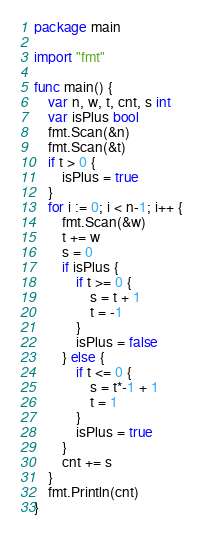Convert code to text. <code><loc_0><loc_0><loc_500><loc_500><_Go_>package main

import "fmt"

func main() {
	var n, w, t, cnt, s int
	var isPlus bool
	fmt.Scan(&n)
	fmt.Scan(&t)
	if t > 0 {
		isPlus = true
	}
	for i := 0; i < n-1; i++ {
		fmt.Scan(&w)
		t += w
		s = 0
		if isPlus {
			if t >= 0 {
				s = t + 1
				t = -1
			}
			isPlus = false
		} else {
			if t <= 0 {
				s = t*-1 + 1
				t = 1
			}
			isPlus = true
		}
		cnt += s
	}
	fmt.Println(cnt)
}
</code> 